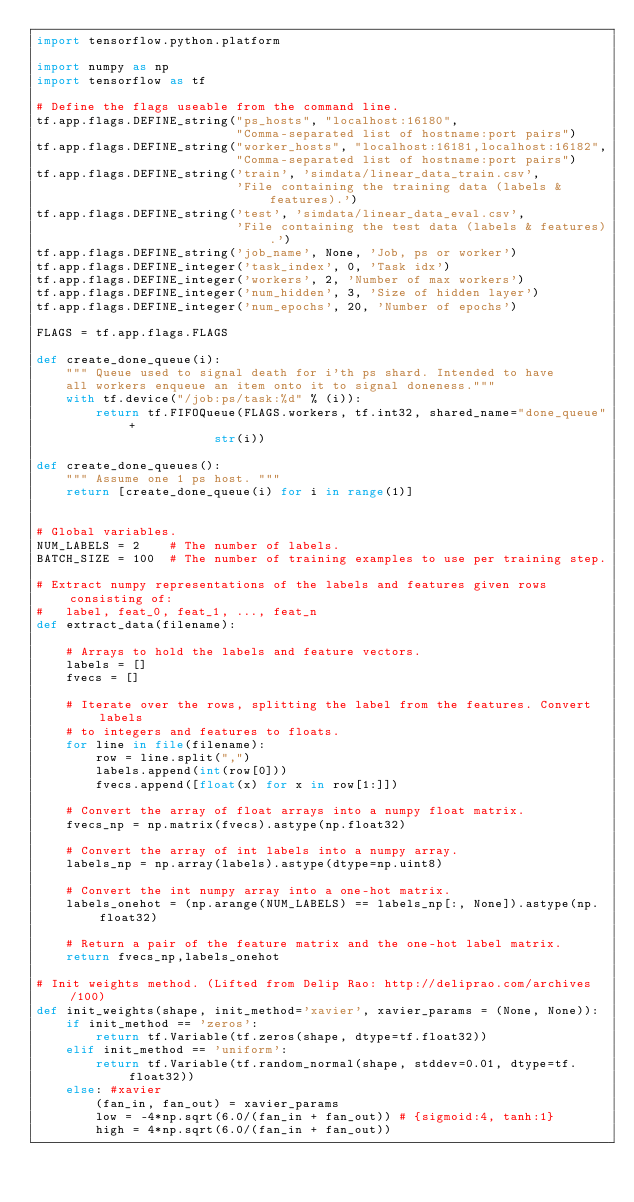<code> <loc_0><loc_0><loc_500><loc_500><_Python_>import tensorflow.python.platform

import numpy as np
import tensorflow as tf

# Define the flags useable from the command line.
tf.app.flags.DEFINE_string("ps_hosts", "localhost:16180",
                           "Comma-separated list of hostname:port pairs")
tf.app.flags.DEFINE_string("worker_hosts", "localhost:16181,localhost:16182",
                           "Comma-separated list of hostname:port pairs")
tf.app.flags.DEFINE_string('train', 'simdata/linear_data_train.csv',
                           'File containing the training data (labels & features).')
tf.app.flags.DEFINE_string('test', 'simdata/linear_data_eval.csv', 
                           'File containing the test data (labels & features).')
tf.app.flags.DEFINE_string('job_name', None, 'Job, ps or worker')
tf.app.flags.DEFINE_integer('task_index', 0, 'Task idx')
tf.app.flags.DEFINE_integer('workers', 2, 'Number of max workers')
tf.app.flags.DEFINE_integer('num_hidden', 3, 'Size of hidden layer')
tf.app.flags.DEFINE_integer('num_epochs', 20, 'Number of epochs') 

FLAGS = tf.app.flags.FLAGS

def create_done_queue(i):
    """ Queue used to signal death for i'th ps shard. Intended to have 
    all workers enqueue an item onto it to signal doneness."""
    with tf.device("/job:ps/task:%d" % (i)):
        return tf.FIFOQueue(FLAGS.workers, tf.int32, shared_name="done_queue"+
                        str(i))
  
def create_done_queues():
    """ Assume one 1 ps host. """
    return [create_done_queue(i) for i in range(1)] 


# Global variables.
NUM_LABELS = 2    # The number of labels.
BATCH_SIZE = 100  # The number of training examples to use per training step.

# Extract numpy representations of the labels and features given rows consisting of:
#   label, feat_0, feat_1, ..., feat_n
def extract_data(filename):

    # Arrays to hold the labels and feature vectors.
    labels = []
    fvecs = []

    # Iterate over the rows, splitting the label from the features. Convert labels
    # to integers and features to floats.
    for line in file(filename):
        row = line.split(",")
        labels.append(int(row[0]))
        fvecs.append([float(x) for x in row[1:]])

    # Convert the array of float arrays into a numpy float matrix.
    fvecs_np = np.matrix(fvecs).astype(np.float32)

    # Convert the array of int labels into a numpy array.
    labels_np = np.array(labels).astype(dtype=np.uint8)

    # Convert the int numpy array into a one-hot matrix.
    labels_onehot = (np.arange(NUM_LABELS) == labels_np[:, None]).astype(np.float32)

    # Return a pair of the feature matrix and the one-hot label matrix.
    return fvecs_np,labels_onehot

# Init weights method. (Lifted from Delip Rao: http://deliprao.com/archives/100)
def init_weights(shape, init_method='xavier', xavier_params = (None, None)):
    if init_method == 'zeros':
        return tf.Variable(tf.zeros(shape, dtype=tf.float32))
    elif init_method == 'uniform':
        return tf.Variable(tf.random_normal(shape, stddev=0.01, dtype=tf.float32))
    else: #xavier
        (fan_in, fan_out) = xavier_params
        low = -4*np.sqrt(6.0/(fan_in + fan_out)) # {sigmoid:4, tanh:1} 
        high = 4*np.sqrt(6.0/(fan_in + fan_out))</code> 